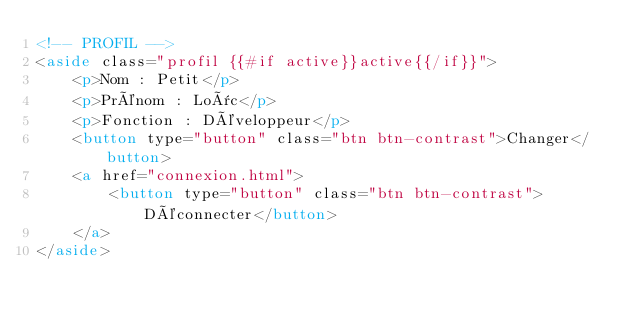Convert code to text. <code><loc_0><loc_0><loc_500><loc_500><_HTML_><!-- PROFIL -->
<aside class="profil {{#if active}}active{{/if}}">
    <p>Nom : Petit</p>
    <p>Prénom : Loïc</p>
    <p>Fonction : Développeur</p>
    <button type="button" class="btn btn-contrast">Changer</button>
    <a href="connexion.html">
        <button type="button" class="btn btn-contrast">Déconnecter</button>
    </a>
</aside>
</code> 